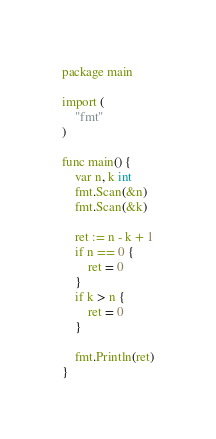Convert code to text. <code><loc_0><loc_0><loc_500><loc_500><_Go_>package main

import (
	"fmt"
)

func main() {
	var n, k int
	fmt.Scan(&n)
	fmt.Scan(&k)

	ret := n - k + 1
	if n == 0 {
		ret = 0
	}
	if k > n {
		ret = 0
	}

	fmt.Println(ret)
}
</code> 